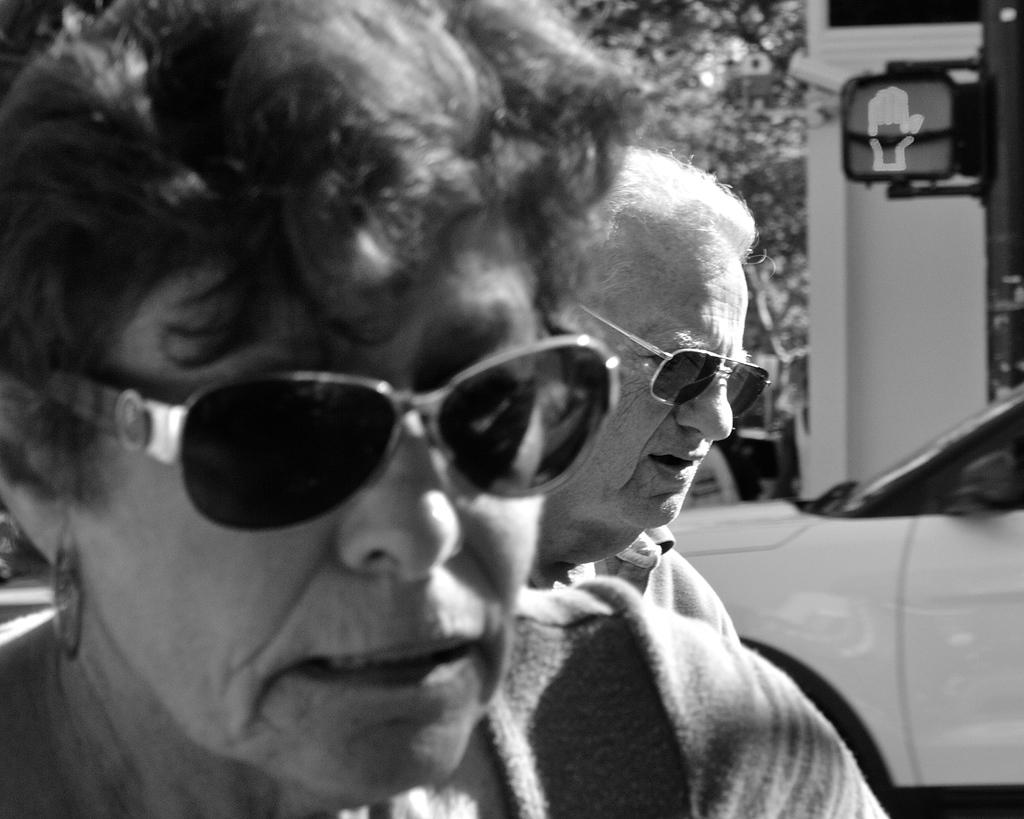How many people are in the image? There are two people in the image. What are the people wearing? The people are wearing goggles. What can be seen in the background of the image? There is a car, a traffic signal, trees, and some unspecified objects in the background of the image. What type of honey is being collected by the governor in the image? There is no governor or honey present in the image. Is there a rock formation visible in the image? There is no rock formation visible in the image. 